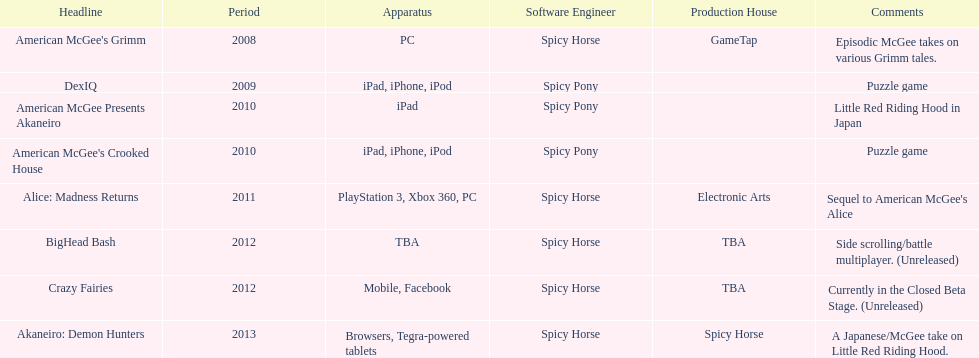What platform was used for the last title on this chart? Browsers, Tegra-powered tablets. 